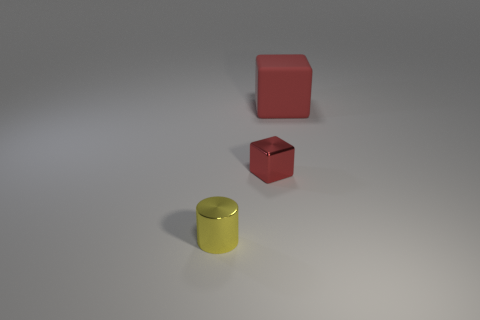What number of tiny things are behind the block in front of the block that is on the right side of the small red thing?
Offer a terse response. 0. Is the number of small yellow objects that are behind the small yellow metallic thing less than the number of big red objects?
Ensure brevity in your answer.  Yes. Is there anything else that has the same shape as the big red rubber object?
Offer a very short reply. Yes. There is a red object to the left of the large thing; what shape is it?
Your answer should be compact. Cube. There is a shiny thing right of the shiny object that is in front of the red object that is to the left of the big red rubber cube; what shape is it?
Keep it short and to the point. Cube. How many objects are either big red objects or shiny cylinders?
Ensure brevity in your answer.  2. There is a object to the left of the small metallic cube; is it the same shape as the tiny object behind the yellow metallic cylinder?
Give a very brief answer. No. How many objects are left of the red matte object and right of the yellow thing?
Provide a short and direct response. 1. What number of other objects are the same size as the red metallic block?
Your response must be concise. 1. There is a object that is both in front of the large red thing and to the right of the yellow shiny cylinder; what material is it?
Your answer should be very brief. Metal. 